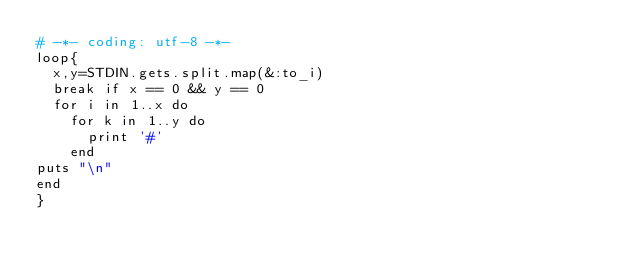Convert code to text. <code><loc_0><loc_0><loc_500><loc_500><_Ruby_># -*- coding: utf-8 -*-
loop{
  x,y=STDIN.gets.split.map(&:to_i)
  break if x == 0 && y == 0 
  for i in 1..x do
    for k in 1..y do
      print '#'
    end
puts "\n"  
end
}</code> 